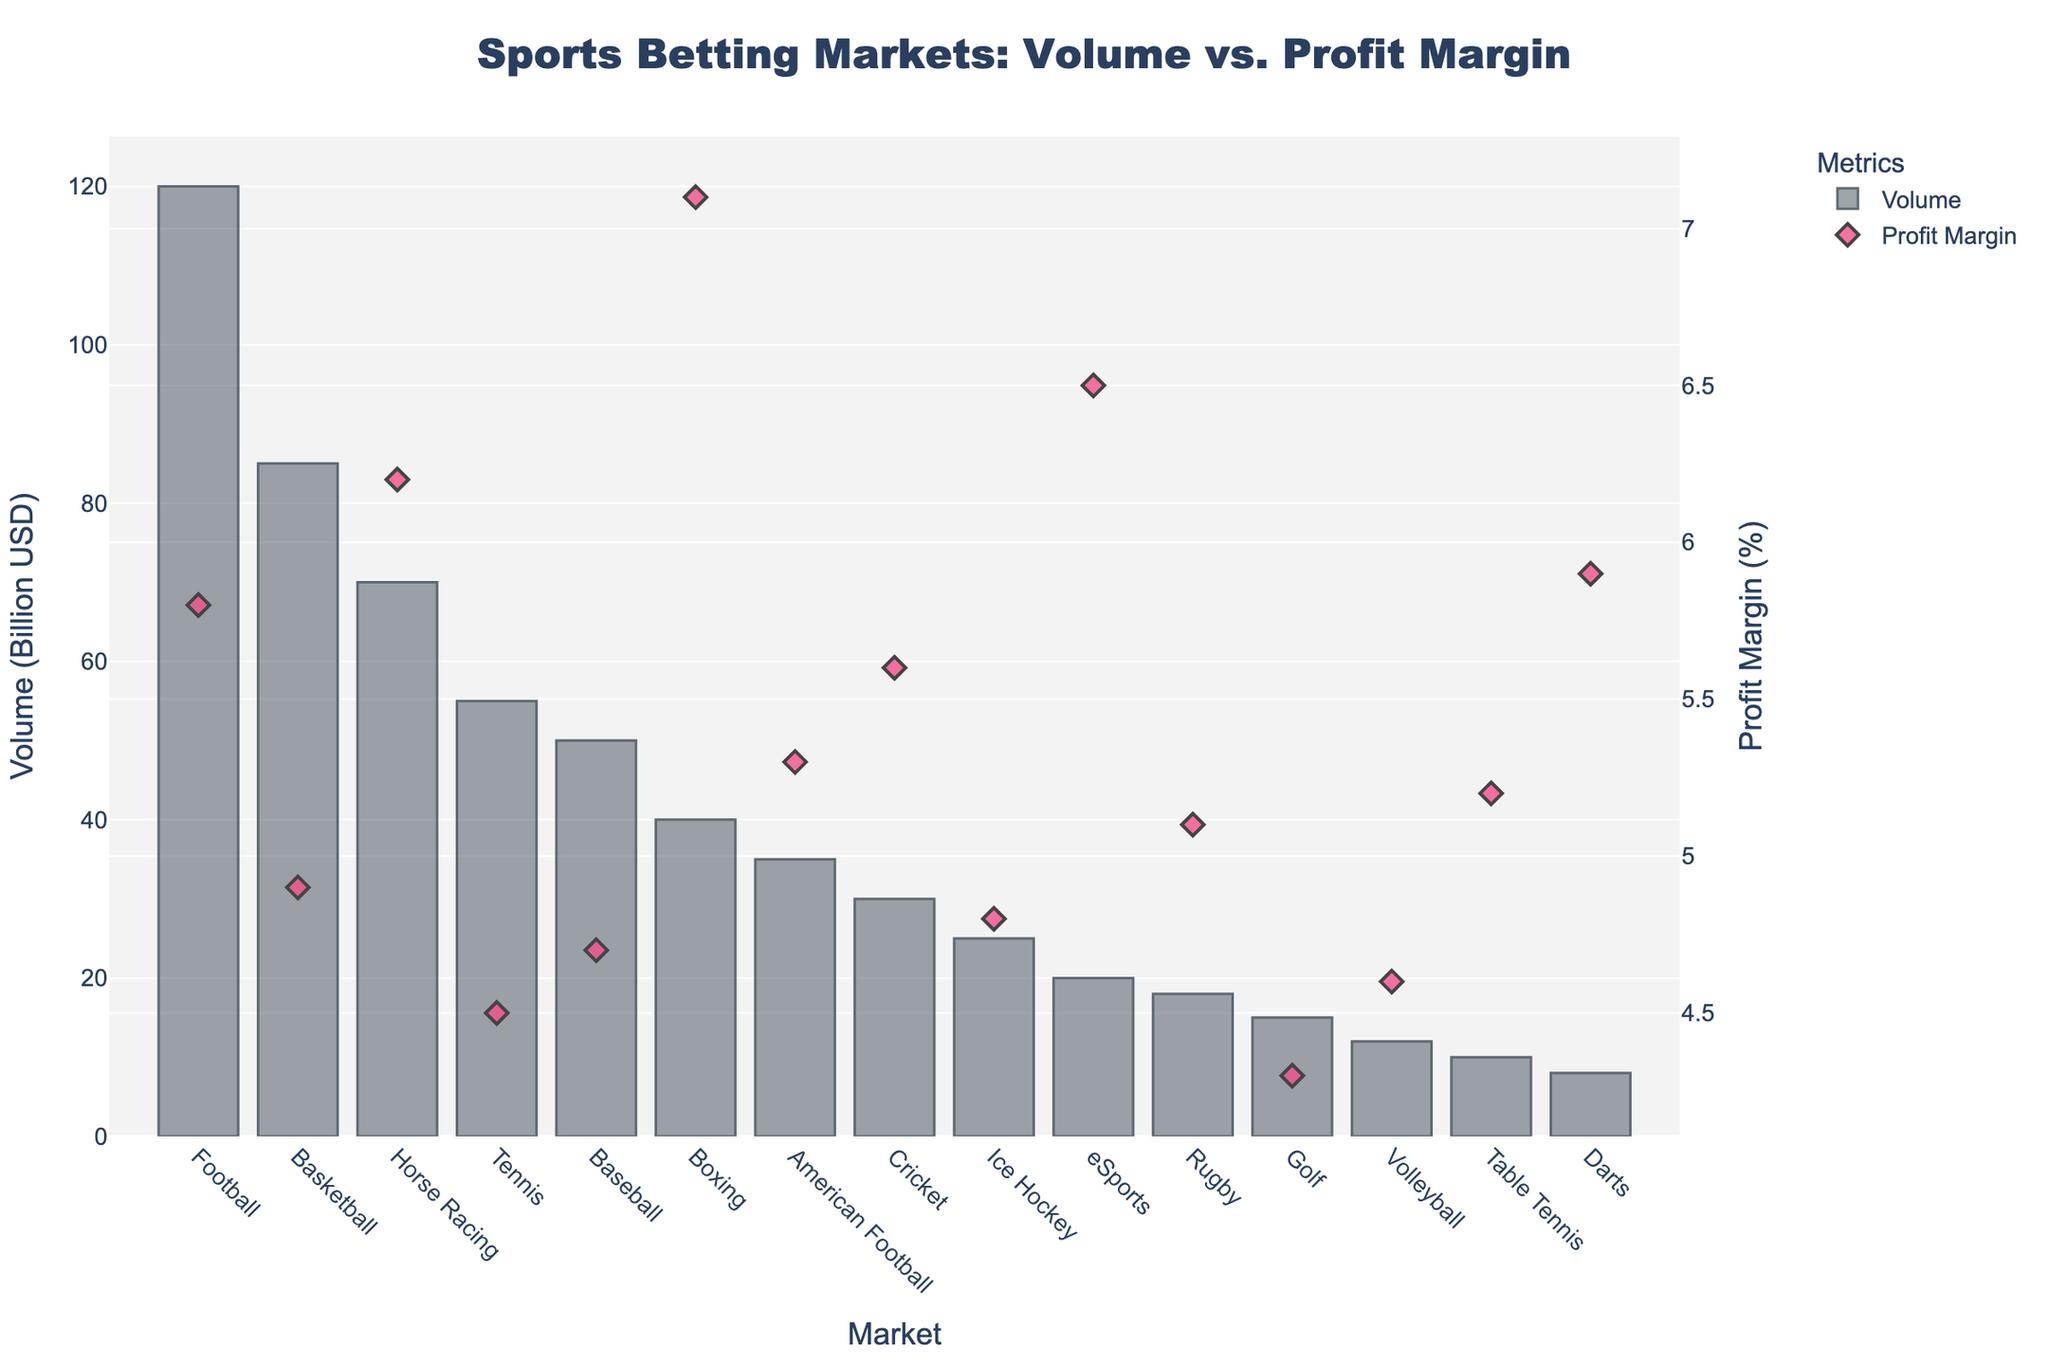Which market has the highest volume? To determine which market has the highest volume, look at the heights of the bars. The tallest bar represents the highest volume.
Answer: Football Which market has the highest profit margin? To find the market with the highest profit margin, observe the scatter points and find the highest point.
Answer: Boxing What is the difference in profit margin between Football and Basketball? First, identify the profit margins for both Football (5.8%) and Basketball (4.9%). Then, subtract the profit margin of Basketball from Football: 5.8% - 4.9% = 0.9%.
Answer: 0.9% Which has a higher volume, Tennis or Baseball? Compare the heights of the bars for Tennis and Baseball. The bar for Baseball is higher than the bar for Tennis.
Answer: Baseball How many markets have a profit margin greater than 5%? Count the number of markets with scatter points positioned above the 5% mark on the y-axis. These markets are Football, Horse Racing, Boxing, American Football, Cricket, eSports, Rugby, Table Tennis, and Darts.
Answer: 9 Which market has the lowest volume but a profit margin greater than 6%? Identify the market with the smallest bar whose scatter point is above the 6% mark. This market is Darts.
Answer: Darts What’s the sum of the volumes of the top three markets by volume? First, find the volumes of the top three markets: Football (120), Basketball (85), and Horse Racing (70). Then, add them together: 120 + 85 + 70 = 275 Billion USD.
Answer: 275 Billion USD Is the profit margin for Golf less than for Ice Hockey? Compare the scatter points for Golf and Ice Hockey. The profit margin for Golf (4.3%) is less than that for Ice Hockey (4.8%).
Answer: Yes What’s the ratio of the volume of Basketball to Cricket? Find the volumes for Basketball (85) and Cricket (30). Then, divide the volume of Basketball by the volume of Cricket: 85 / 30 ≈ 2.83.
Answer: 2.83 Which market has a profit margin closest to the average profit margin of all markets? Calculate the average profit margin of all markets. Sum the profit margins (78.9%) and divide by the number of markets (15): 78.9% / 15 ≈ 5.26%. The market closest to this value is American Football (5.3%).
Answer: American Football 